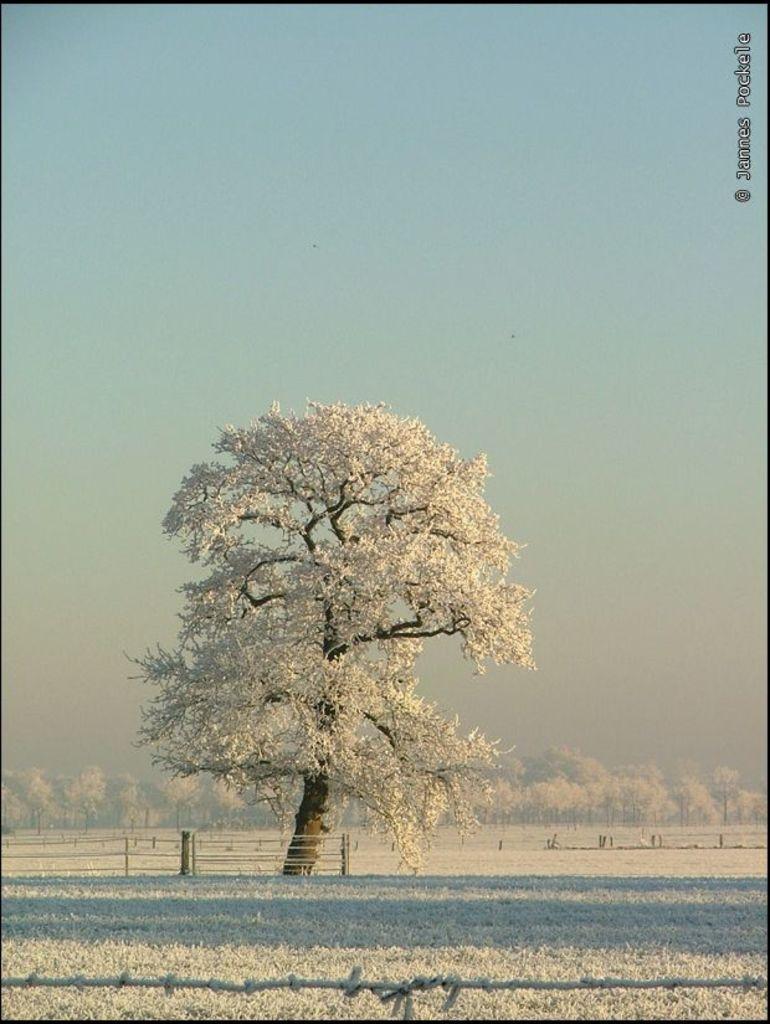Please provide a concise description of this image. In this picture there is a white color tree in the center of the image and there is snow floor at the bottom side of the image, there is a rope at the bottom side of the image and there are white trees in the background area of the image. 